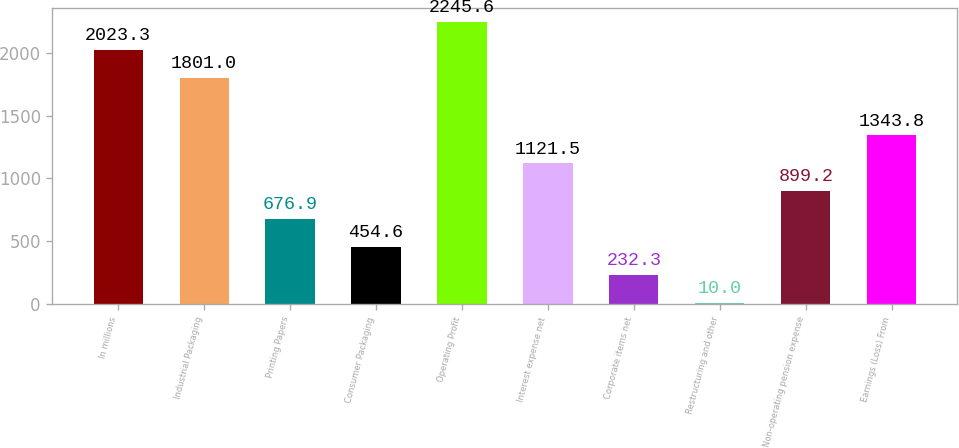Convert chart to OTSL. <chart><loc_0><loc_0><loc_500><loc_500><bar_chart><fcel>In millions<fcel>Industrial Packaging<fcel>Printing Papers<fcel>Consumer Packaging<fcel>Operating Profit<fcel>Interest expense net<fcel>Corporate items net<fcel>Restructuring and other<fcel>Non-operating pension expense<fcel>Earnings (Loss) From<nl><fcel>2023.3<fcel>1801<fcel>676.9<fcel>454.6<fcel>2245.6<fcel>1121.5<fcel>232.3<fcel>10<fcel>899.2<fcel>1343.8<nl></chart> 